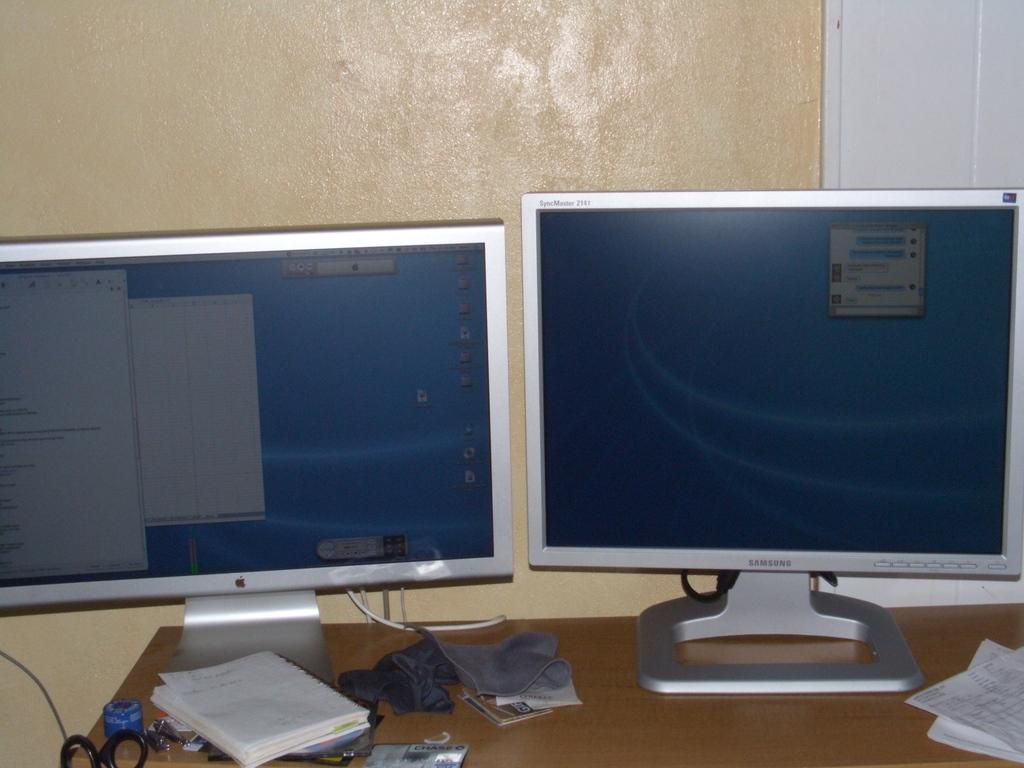<image>
Give a short and clear explanation of the subsequent image. Two monitors side by side with one that says Samsung on it. 